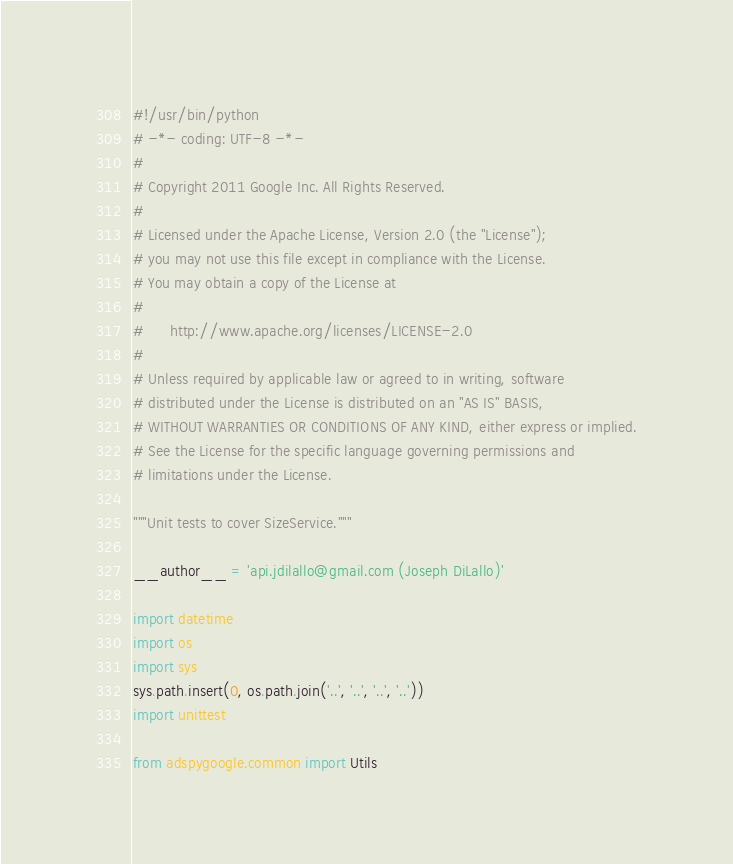<code> <loc_0><loc_0><loc_500><loc_500><_Python_>#!/usr/bin/python
# -*- coding: UTF-8 -*-
#
# Copyright 2011 Google Inc. All Rights Reserved.
#
# Licensed under the Apache License, Version 2.0 (the "License");
# you may not use this file except in compliance with the License.
# You may obtain a copy of the License at
#
#      http://www.apache.org/licenses/LICENSE-2.0
#
# Unless required by applicable law or agreed to in writing, software
# distributed under the License is distributed on an "AS IS" BASIS,
# WITHOUT WARRANTIES OR CONDITIONS OF ANY KIND, either express or implied.
# See the License for the specific language governing permissions and
# limitations under the License.

"""Unit tests to cover SizeService."""

__author__ = 'api.jdilallo@gmail.com (Joseph DiLallo)'

import datetime
import os
import sys
sys.path.insert(0, os.path.join('..', '..', '..', '..'))
import unittest

from adspygoogle.common import Utils</code> 